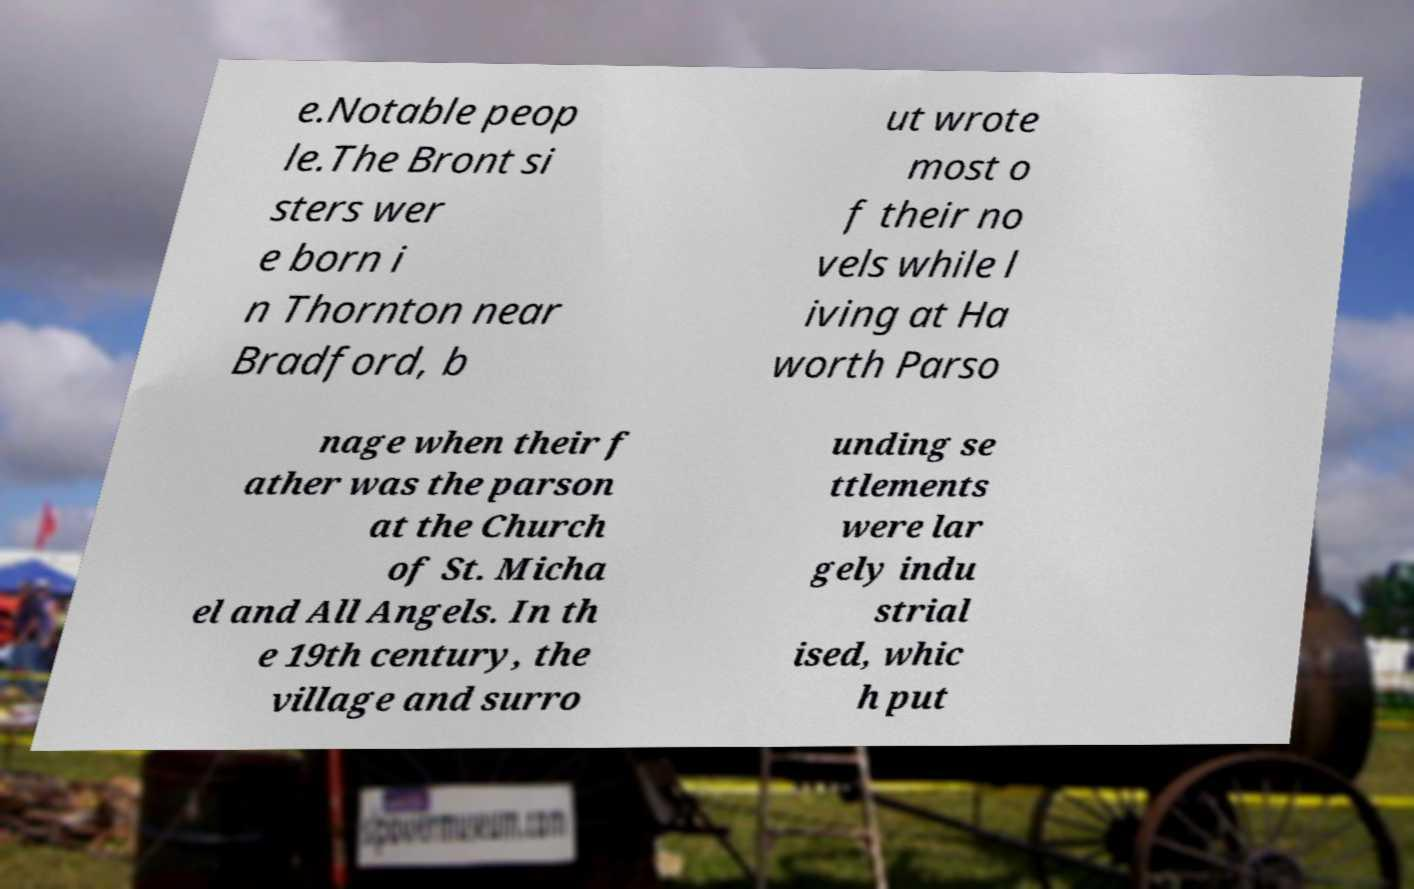For documentation purposes, I need the text within this image transcribed. Could you provide that? e.Notable peop le.The Bront si sters wer e born i n Thornton near Bradford, b ut wrote most o f their no vels while l iving at Ha worth Parso nage when their f ather was the parson at the Church of St. Micha el and All Angels. In th e 19th century, the village and surro unding se ttlements were lar gely indu strial ised, whic h put 